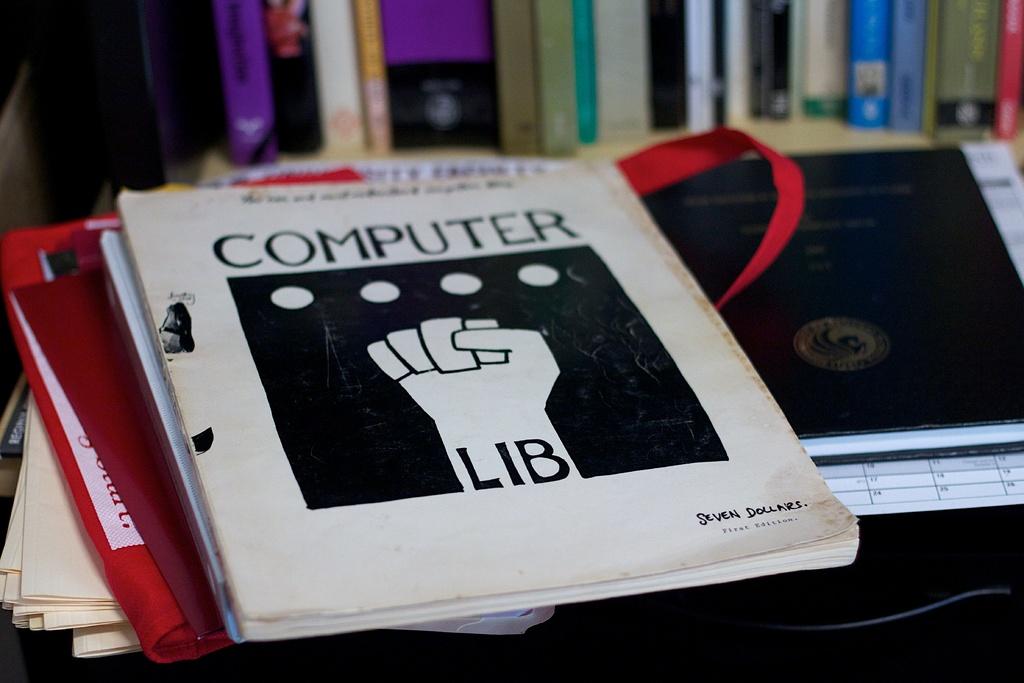What is the title of this book?
Make the answer very short. Computer lib. 